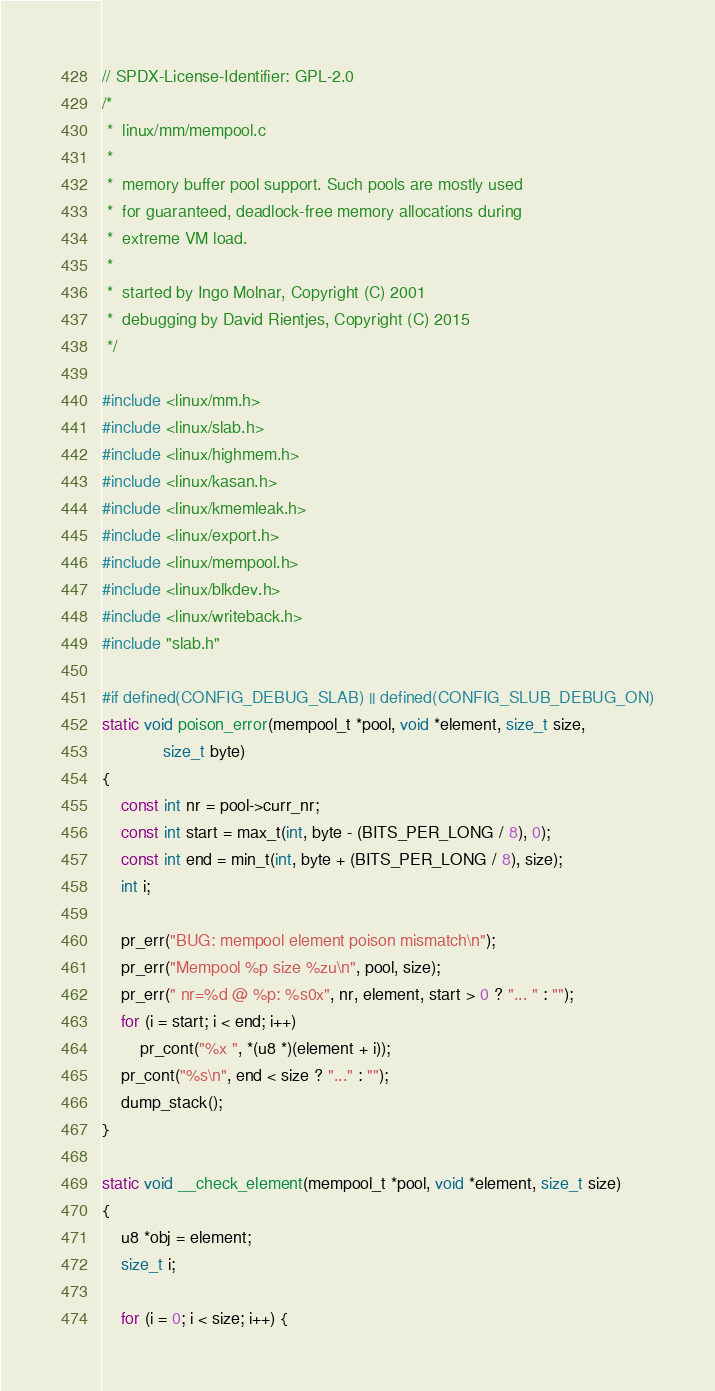<code> <loc_0><loc_0><loc_500><loc_500><_C_>// SPDX-License-Identifier: GPL-2.0
/*
 *  linux/mm/mempool.c
 *
 *  memory buffer pool support. Such pools are mostly used
 *  for guaranteed, deadlock-free memory allocations during
 *  extreme VM load.
 *
 *  started by Ingo Molnar, Copyright (C) 2001
 *  debugging by David Rientjes, Copyright (C) 2015
 */

#include <linux/mm.h>
#include <linux/slab.h>
#include <linux/highmem.h>
#include <linux/kasan.h>
#include <linux/kmemleak.h>
#include <linux/export.h>
#include <linux/mempool.h>
#include <linux/blkdev.h>
#include <linux/writeback.h>
#include "slab.h"

#if defined(CONFIG_DEBUG_SLAB) || defined(CONFIG_SLUB_DEBUG_ON)
static void poison_error(mempool_t *pool, void *element, size_t size,
			 size_t byte)
{
	const int nr = pool->curr_nr;
	const int start = max_t(int, byte - (BITS_PER_LONG / 8), 0);
	const int end = min_t(int, byte + (BITS_PER_LONG / 8), size);
	int i;

	pr_err("BUG: mempool element poison mismatch\n");
	pr_err("Mempool %p size %zu\n", pool, size);
	pr_err(" nr=%d @ %p: %s0x", nr, element, start > 0 ? "... " : "");
	for (i = start; i < end; i++)
		pr_cont("%x ", *(u8 *)(element + i));
	pr_cont("%s\n", end < size ? "..." : "");
	dump_stack();
}

static void __check_element(mempool_t *pool, void *element, size_t size)
{
	u8 *obj = element;
	size_t i;

	for (i = 0; i < size; i++) {</code> 